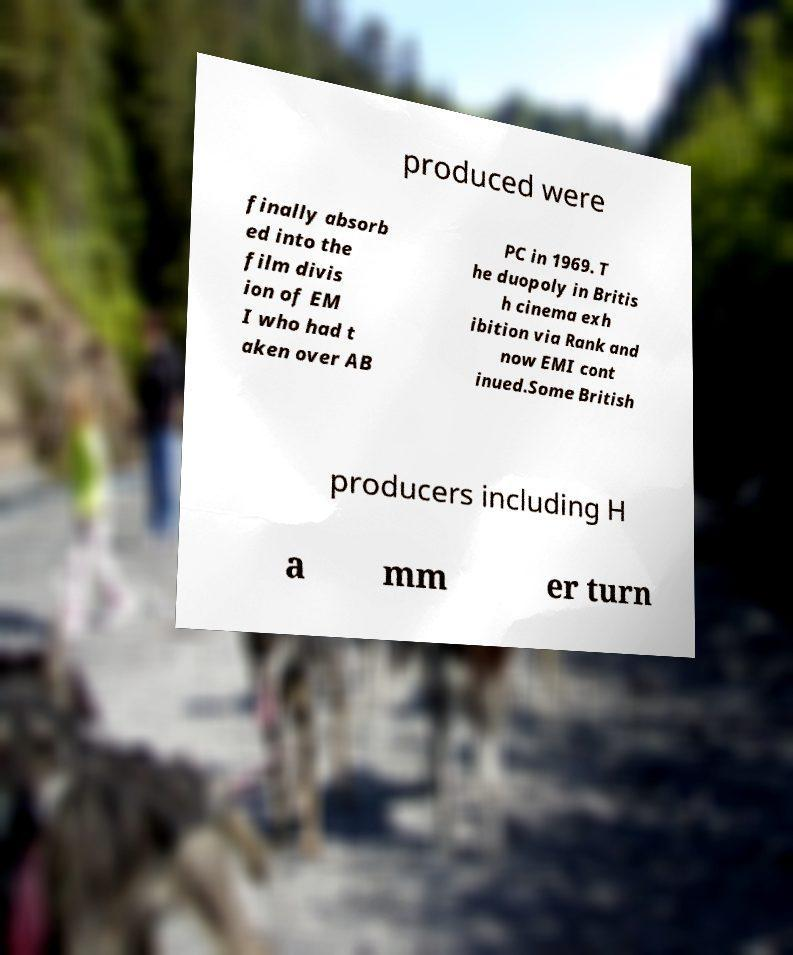What messages or text are displayed in this image? I need them in a readable, typed format. produced were finally absorb ed into the film divis ion of EM I who had t aken over AB PC in 1969. T he duopoly in Britis h cinema exh ibition via Rank and now EMI cont inued.Some British producers including H a mm er turn 